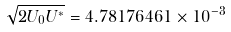<formula> <loc_0><loc_0><loc_500><loc_500>\sqrt { 2 U _ { 0 } U ^ { * } } = 4 . 7 8 1 7 6 4 6 1 \times 1 0 ^ { - 3 }</formula> 